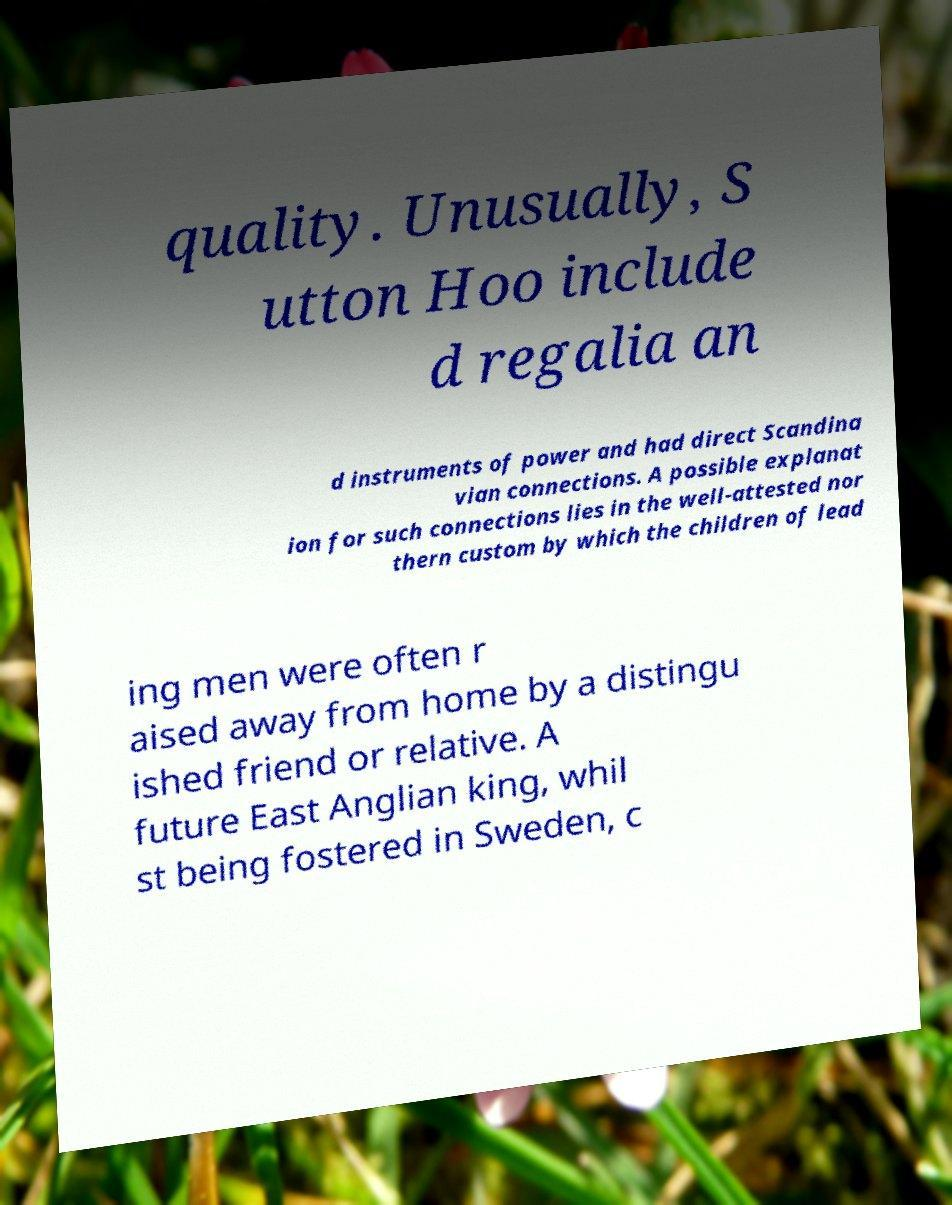For documentation purposes, I need the text within this image transcribed. Could you provide that? quality. Unusually, S utton Hoo include d regalia an d instruments of power and had direct Scandina vian connections. A possible explanat ion for such connections lies in the well-attested nor thern custom by which the children of lead ing men were often r aised away from home by a distingu ished friend or relative. A future East Anglian king, whil st being fostered in Sweden, c 